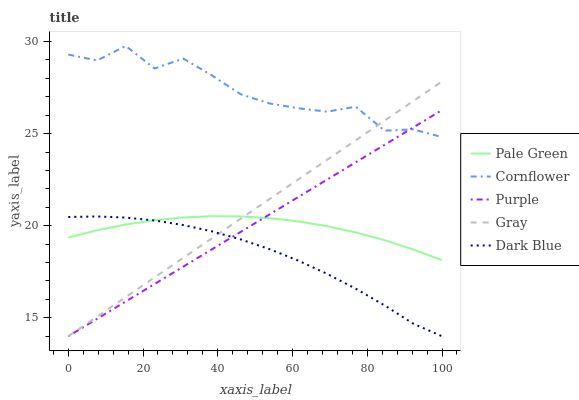Does Dark Blue have the minimum area under the curve?
Answer yes or no. Yes. Does Cornflower have the maximum area under the curve?
Answer yes or no. Yes. Does Pale Green have the minimum area under the curve?
Answer yes or no. No. Does Pale Green have the maximum area under the curve?
Answer yes or no. No. Is Gray the smoothest?
Answer yes or no. Yes. Is Cornflower the roughest?
Answer yes or no. Yes. Is Pale Green the smoothest?
Answer yes or no. No. Is Pale Green the roughest?
Answer yes or no. No. Does Pale Green have the lowest value?
Answer yes or no. No. Does Pale Green have the highest value?
Answer yes or no. No. Is Dark Blue less than Cornflower?
Answer yes or no. Yes. Is Cornflower greater than Pale Green?
Answer yes or no. Yes. Does Dark Blue intersect Cornflower?
Answer yes or no. No. 